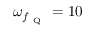Convert formula to latex. <formula><loc_0><loc_0><loc_500><loc_500>\omega _ { f _ { Q } } = 1 0</formula> 